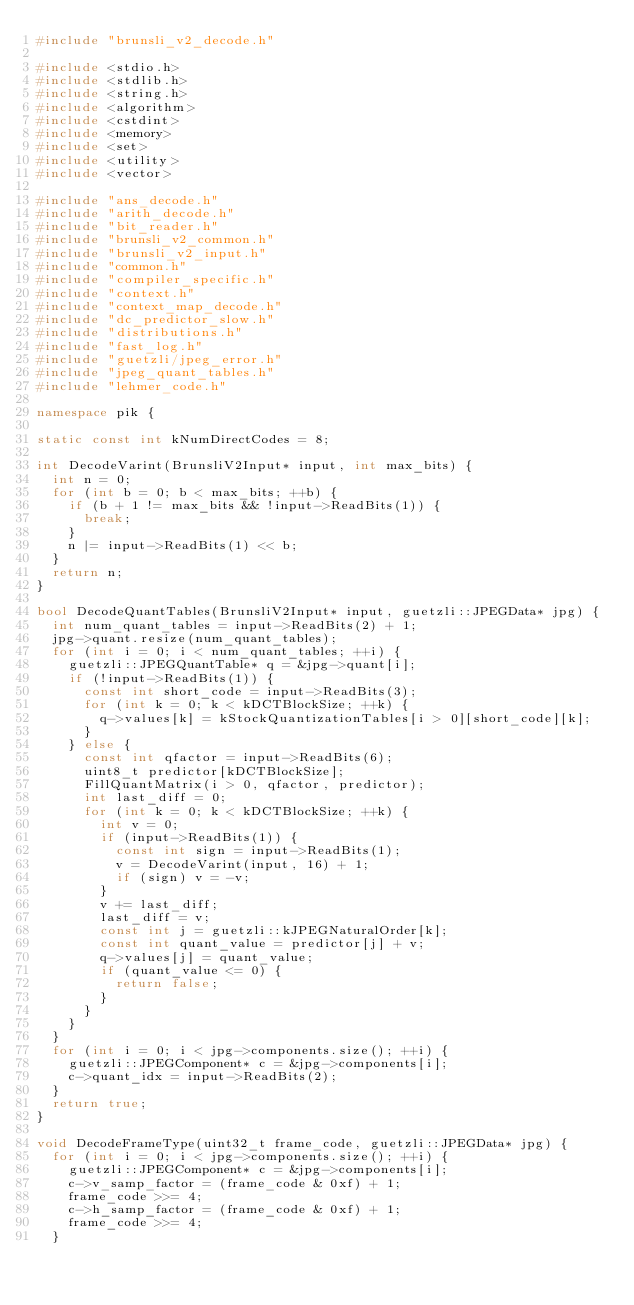Convert code to text. <code><loc_0><loc_0><loc_500><loc_500><_C++_>#include "brunsli_v2_decode.h"

#include <stdio.h>
#include <stdlib.h>
#include <string.h>
#include <algorithm>
#include <cstdint>
#include <memory>
#include <set>
#include <utility>
#include <vector>

#include "ans_decode.h"
#include "arith_decode.h"
#include "bit_reader.h"
#include "brunsli_v2_common.h"
#include "brunsli_v2_input.h"
#include "common.h"
#include "compiler_specific.h"
#include "context.h"
#include "context_map_decode.h"
#include "dc_predictor_slow.h"
#include "distributions.h"
#include "fast_log.h"
#include "guetzli/jpeg_error.h"
#include "jpeg_quant_tables.h"
#include "lehmer_code.h"

namespace pik {

static const int kNumDirectCodes = 8;

int DecodeVarint(BrunsliV2Input* input, int max_bits) {
  int n = 0;
  for (int b = 0; b < max_bits; ++b) {
    if (b + 1 != max_bits && !input->ReadBits(1)) {
      break;
    }
    n |= input->ReadBits(1) << b;
  }
  return n;
}

bool DecodeQuantTables(BrunsliV2Input* input, guetzli::JPEGData* jpg) {
  int num_quant_tables = input->ReadBits(2) + 1;
  jpg->quant.resize(num_quant_tables);
  for (int i = 0; i < num_quant_tables; ++i) {
    guetzli::JPEGQuantTable* q = &jpg->quant[i];
    if (!input->ReadBits(1)) {
      const int short_code = input->ReadBits(3);
      for (int k = 0; k < kDCTBlockSize; ++k) {
        q->values[k] = kStockQuantizationTables[i > 0][short_code][k];
      }
    } else {
      const int qfactor = input->ReadBits(6);
      uint8_t predictor[kDCTBlockSize];
      FillQuantMatrix(i > 0, qfactor, predictor);
      int last_diff = 0;
      for (int k = 0; k < kDCTBlockSize; ++k) {
        int v = 0;
        if (input->ReadBits(1)) {
          const int sign = input->ReadBits(1);
          v = DecodeVarint(input, 16) + 1;
          if (sign) v = -v;
        }
        v += last_diff;
        last_diff = v;
        const int j = guetzli::kJPEGNaturalOrder[k];
        const int quant_value = predictor[j] + v;
        q->values[j] = quant_value;
        if (quant_value <= 0) {
          return false;
        }
      }
    }
  }
  for (int i = 0; i < jpg->components.size(); ++i) {
    guetzli::JPEGComponent* c = &jpg->components[i];
    c->quant_idx = input->ReadBits(2);
  }
  return true;
}

void DecodeFrameType(uint32_t frame_code, guetzli::JPEGData* jpg) {
  for (int i = 0; i < jpg->components.size(); ++i) {
    guetzli::JPEGComponent* c = &jpg->components[i];
    c->v_samp_factor = (frame_code & 0xf) + 1;
    frame_code >>= 4;
    c->h_samp_factor = (frame_code & 0xf) + 1;
    frame_code >>= 4;
  }</code> 